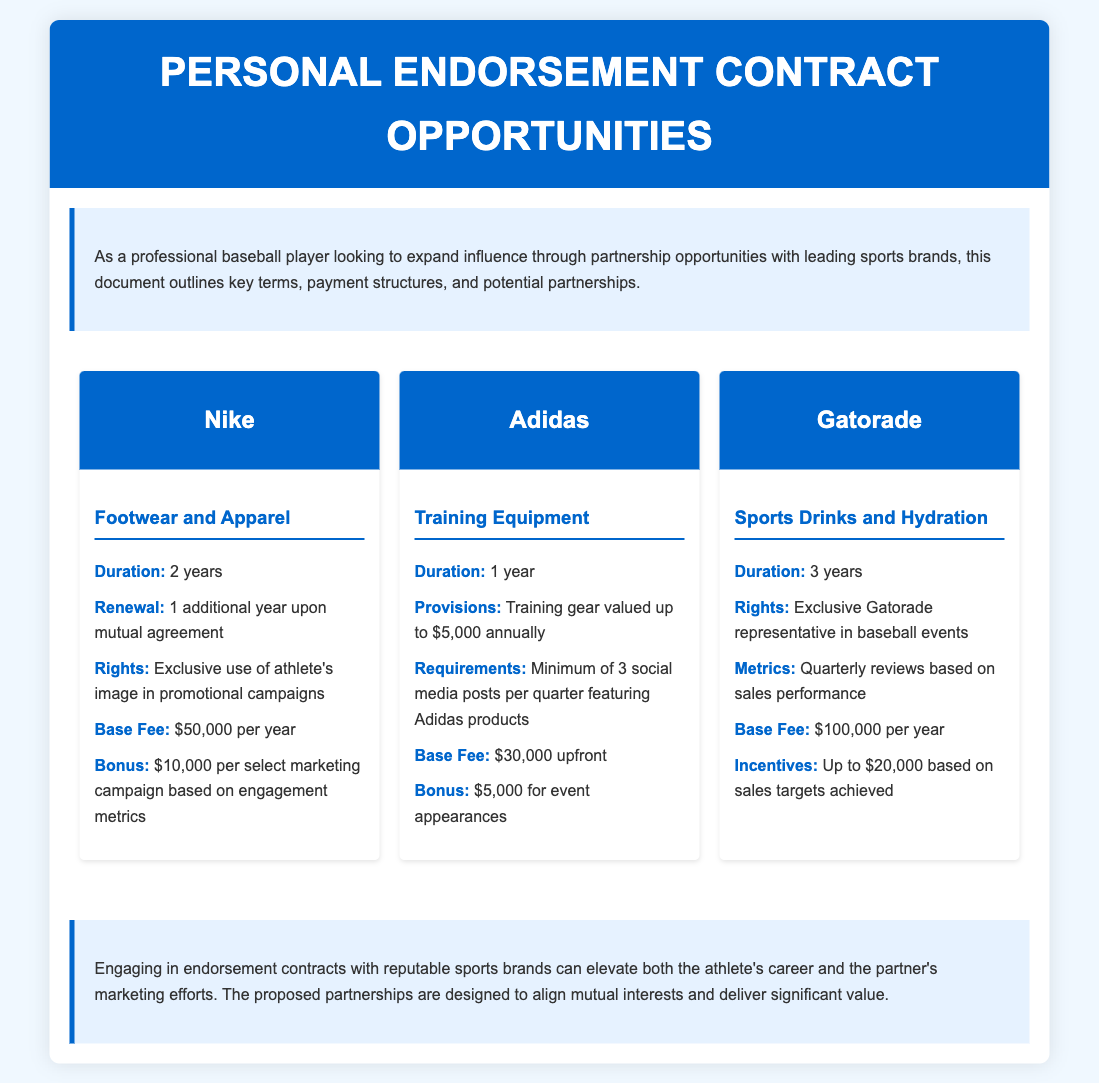what is the duration of the Nike contract? The duration of the Nike contract is specified in the document as 2 years.
Answer: 2 years what is the base fee for the Adidas partnership? The base fee for the Adidas partnership is clearly mentioned in the document as $30,000 upfront.
Answer: $30,000 upfront how much can be earned from bonuses in the Gatorade contract? The bonuses of up to $20,000 based on sales targets achieved can be earned in the Gatorade contract, adding to the base fee.
Answer: $20,000 what is the renewal option for the Nike endorsement? The renewal option for the Nike endorsement is stated as 1 additional year upon mutual agreement.
Answer: 1 additional year how many social media posts are required per quarter for Adidas? The document indicates that a minimum of 3 social media posts per quarter featuring Adidas products is required.
Answer: 3 social media posts what rights does the Gatorade contract provide? The Gatorade contract provides the exclusive rights to be the Gatorade representative in baseball events as stated.
Answer: Exclusive Gatorade representative what type of products is involved in the partnership with Adidas? The type of products involved in the partnership with Adidas is training equipment.
Answer: Training equipment how often are reviews conducted in the Gatorade contract? The document specifies that reviews are conducted quarterly based on sales performance.
Answer: Quarterly what is the provision for training gear in the Adidas agreement? The provision for training gear in the Adidas agreement is valued up to $5,000 annually.
Answer: $5,000 annually 